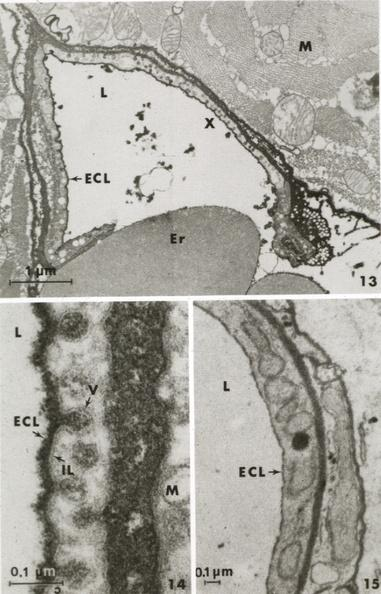s intraductal papillomatosis present?
Answer the question using a single word or phrase. No 